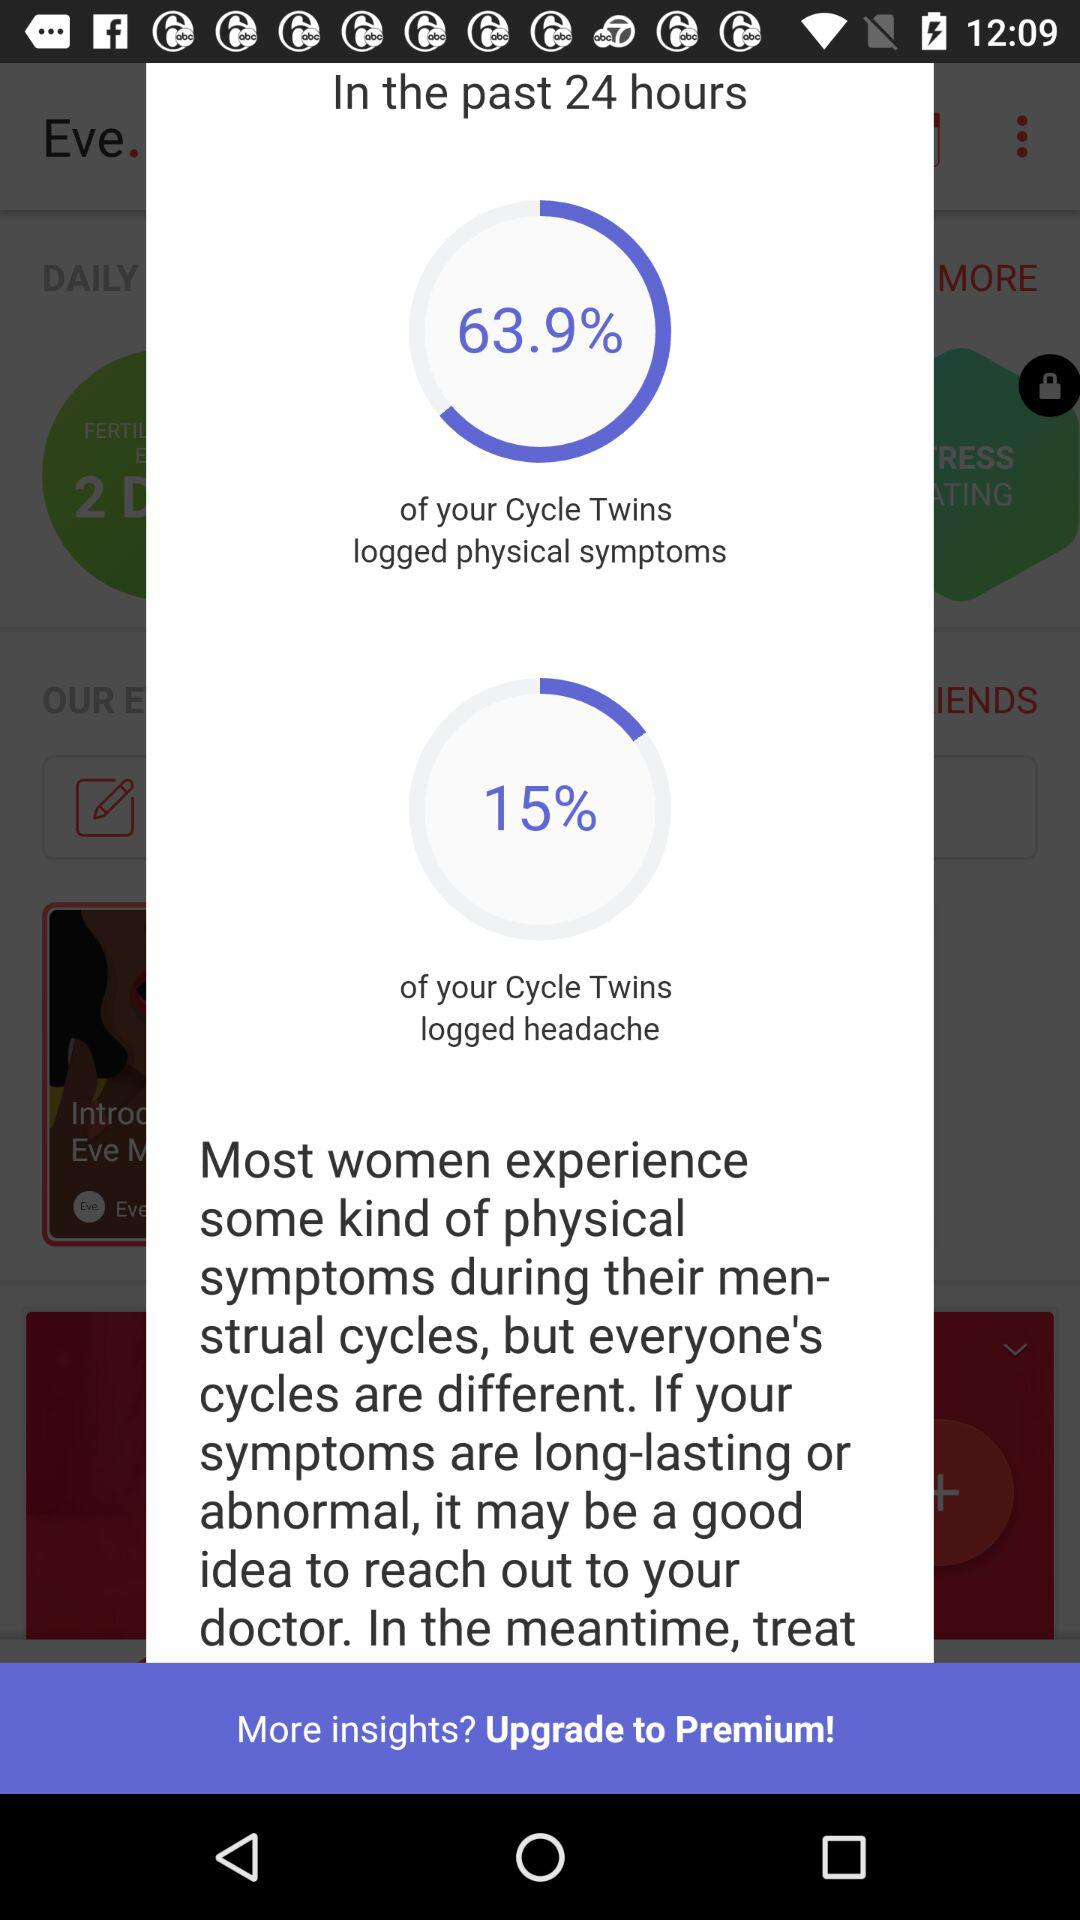What percentage of Cycle Twins logged headache in the past 24 hours?
Answer the question using a single word or phrase. 15% 